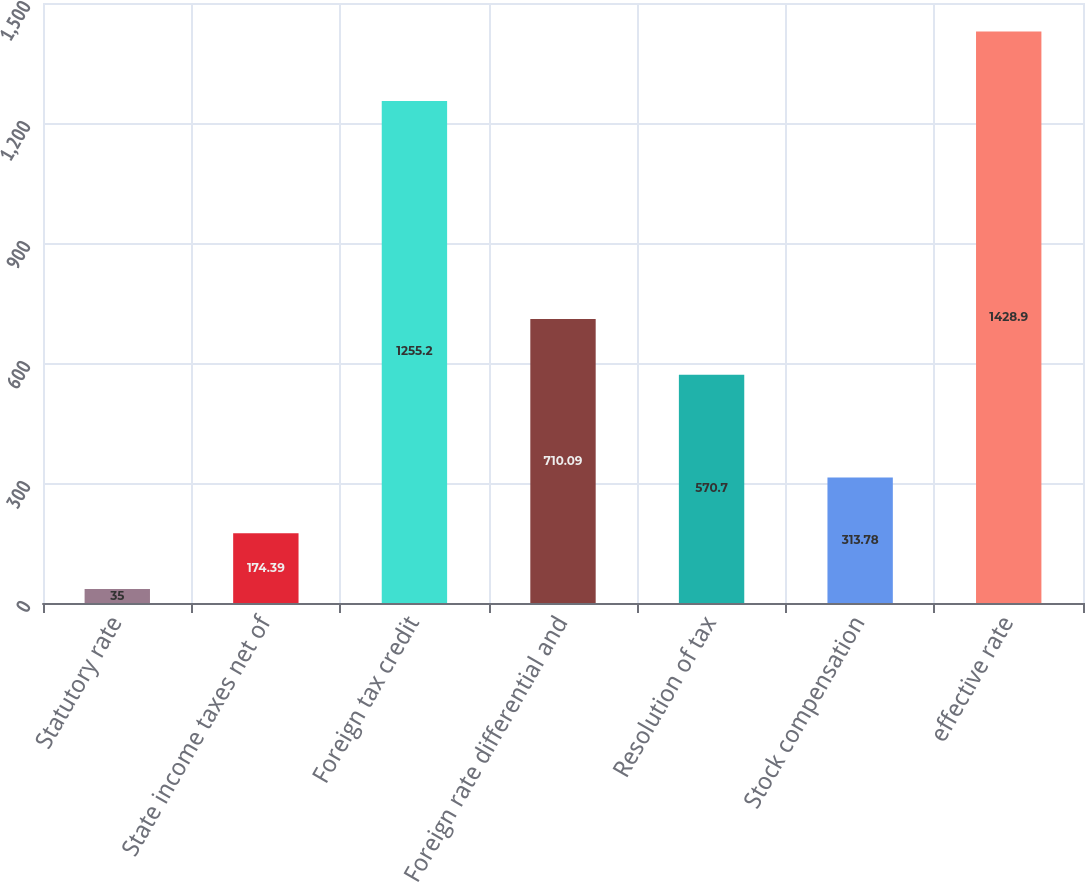Convert chart to OTSL. <chart><loc_0><loc_0><loc_500><loc_500><bar_chart><fcel>Statutory rate<fcel>State income taxes net of<fcel>Foreign tax credit<fcel>Foreign rate differential and<fcel>Resolution of tax<fcel>Stock compensation<fcel>effective rate<nl><fcel>35<fcel>174.39<fcel>1255.2<fcel>710.09<fcel>570.7<fcel>313.78<fcel>1428.9<nl></chart> 